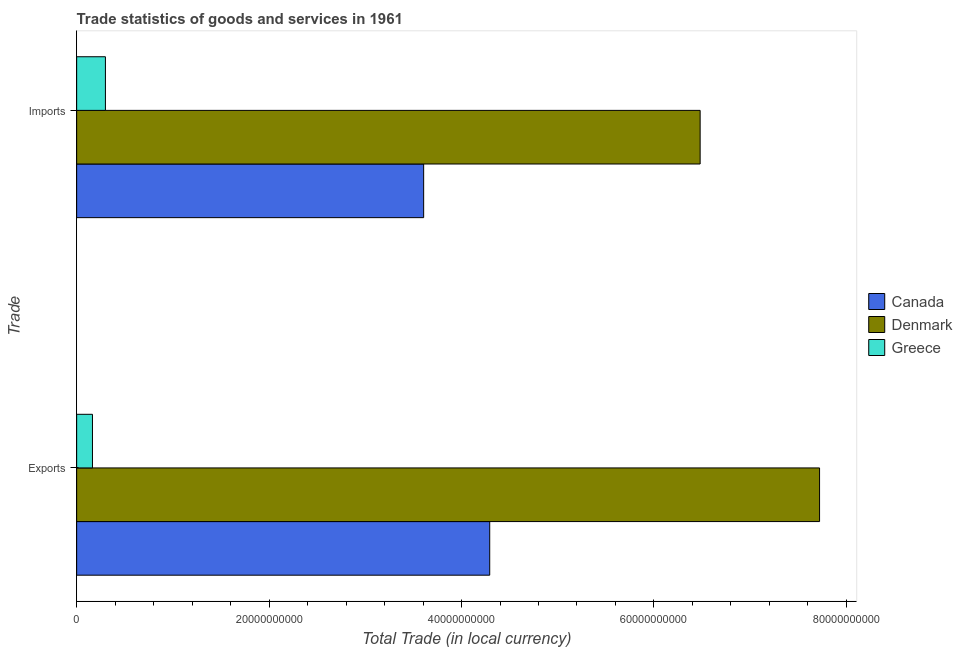How many different coloured bars are there?
Keep it short and to the point. 3. How many groups of bars are there?
Your response must be concise. 2. Are the number of bars per tick equal to the number of legend labels?
Make the answer very short. Yes. How many bars are there on the 2nd tick from the top?
Make the answer very short. 3. What is the label of the 1st group of bars from the top?
Your answer should be compact. Imports. What is the imports of goods and services in Greece?
Your answer should be very brief. 2.99e+09. Across all countries, what is the maximum imports of goods and services?
Offer a very short reply. 6.48e+1. Across all countries, what is the minimum export of goods and services?
Offer a very short reply. 1.64e+09. In which country was the export of goods and services maximum?
Offer a terse response. Denmark. What is the total imports of goods and services in the graph?
Provide a short and direct response. 1.04e+11. What is the difference between the imports of goods and services in Canada and that in Denmark?
Ensure brevity in your answer.  -2.87e+1. What is the difference between the imports of goods and services in Greece and the export of goods and services in Canada?
Provide a short and direct response. -3.99e+1. What is the average export of goods and services per country?
Your answer should be very brief. 4.06e+1. What is the difference between the imports of goods and services and export of goods and services in Denmark?
Offer a terse response. -1.24e+1. What is the ratio of the export of goods and services in Canada to that in Denmark?
Give a very brief answer. 0.56. In how many countries, is the export of goods and services greater than the average export of goods and services taken over all countries?
Your answer should be very brief. 2. What does the 1st bar from the top in Imports represents?
Offer a very short reply. Greece. What does the 1st bar from the bottom in Imports represents?
Offer a terse response. Canada. Are all the bars in the graph horizontal?
Make the answer very short. Yes. What is the difference between two consecutive major ticks on the X-axis?
Your answer should be very brief. 2.00e+1. Does the graph contain any zero values?
Keep it short and to the point. No. How are the legend labels stacked?
Offer a terse response. Vertical. What is the title of the graph?
Your answer should be very brief. Trade statistics of goods and services in 1961. Does "Somalia" appear as one of the legend labels in the graph?
Your response must be concise. No. What is the label or title of the X-axis?
Give a very brief answer. Total Trade (in local currency). What is the label or title of the Y-axis?
Offer a terse response. Trade. What is the Total Trade (in local currency) of Canada in Exports?
Your answer should be very brief. 4.29e+1. What is the Total Trade (in local currency) of Denmark in Exports?
Make the answer very short. 7.72e+1. What is the Total Trade (in local currency) in Greece in Exports?
Provide a short and direct response. 1.64e+09. What is the Total Trade (in local currency) in Canada in Imports?
Offer a very short reply. 3.61e+1. What is the Total Trade (in local currency) in Denmark in Imports?
Provide a short and direct response. 6.48e+1. What is the Total Trade (in local currency) of Greece in Imports?
Your response must be concise. 2.99e+09. Across all Trade, what is the maximum Total Trade (in local currency) in Canada?
Offer a terse response. 4.29e+1. Across all Trade, what is the maximum Total Trade (in local currency) of Denmark?
Provide a short and direct response. 7.72e+1. Across all Trade, what is the maximum Total Trade (in local currency) in Greece?
Keep it short and to the point. 2.99e+09. Across all Trade, what is the minimum Total Trade (in local currency) in Canada?
Keep it short and to the point. 3.61e+1. Across all Trade, what is the minimum Total Trade (in local currency) in Denmark?
Offer a terse response. 6.48e+1. Across all Trade, what is the minimum Total Trade (in local currency) of Greece?
Make the answer very short. 1.64e+09. What is the total Total Trade (in local currency) of Canada in the graph?
Provide a succinct answer. 7.90e+1. What is the total Total Trade (in local currency) in Denmark in the graph?
Your answer should be compact. 1.42e+11. What is the total Total Trade (in local currency) of Greece in the graph?
Offer a very short reply. 4.63e+09. What is the difference between the Total Trade (in local currency) of Canada in Exports and that in Imports?
Your answer should be very brief. 6.87e+09. What is the difference between the Total Trade (in local currency) of Denmark in Exports and that in Imports?
Offer a terse response. 1.24e+1. What is the difference between the Total Trade (in local currency) in Greece in Exports and that in Imports?
Offer a terse response. -1.35e+09. What is the difference between the Total Trade (in local currency) of Canada in Exports and the Total Trade (in local currency) of Denmark in Imports?
Offer a very short reply. -2.19e+1. What is the difference between the Total Trade (in local currency) in Canada in Exports and the Total Trade (in local currency) in Greece in Imports?
Provide a succinct answer. 3.99e+1. What is the difference between the Total Trade (in local currency) in Denmark in Exports and the Total Trade (in local currency) in Greece in Imports?
Your response must be concise. 7.42e+1. What is the average Total Trade (in local currency) in Canada per Trade?
Your answer should be very brief. 3.95e+1. What is the average Total Trade (in local currency) of Denmark per Trade?
Your answer should be very brief. 7.10e+1. What is the average Total Trade (in local currency) in Greece per Trade?
Your response must be concise. 2.32e+09. What is the difference between the Total Trade (in local currency) in Canada and Total Trade (in local currency) in Denmark in Exports?
Your answer should be compact. -3.43e+1. What is the difference between the Total Trade (in local currency) of Canada and Total Trade (in local currency) of Greece in Exports?
Your answer should be very brief. 4.13e+1. What is the difference between the Total Trade (in local currency) in Denmark and Total Trade (in local currency) in Greece in Exports?
Provide a short and direct response. 7.56e+1. What is the difference between the Total Trade (in local currency) of Canada and Total Trade (in local currency) of Denmark in Imports?
Your answer should be compact. -2.87e+1. What is the difference between the Total Trade (in local currency) of Canada and Total Trade (in local currency) of Greece in Imports?
Your response must be concise. 3.31e+1. What is the difference between the Total Trade (in local currency) in Denmark and Total Trade (in local currency) in Greece in Imports?
Provide a succinct answer. 6.18e+1. What is the ratio of the Total Trade (in local currency) of Canada in Exports to that in Imports?
Ensure brevity in your answer.  1.19. What is the ratio of the Total Trade (in local currency) of Denmark in Exports to that in Imports?
Keep it short and to the point. 1.19. What is the ratio of the Total Trade (in local currency) of Greece in Exports to that in Imports?
Keep it short and to the point. 0.55. What is the difference between the highest and the second highest Total Trade (in local currency) in Canada?
Ensure brevity in your answer.  6.87e+09. What is the difference between the highest and the second highest Total Trade (in local currency) of Denmark?
Offer a terse response. 1.24e+1. What is the difference between the highest and the second highest Total Trade (in local currency) in Greece?
Make the answer very short. 1.35e+09. What is the difference between the highest and the lowest Total Trade (in local currency) in Canada?
Ensure brevity in your answer.  6.87e+09. What is the difference between the highest and the lowest Total Trade (in local currency) in Denmark?
Provide a succinct answer. 1.24e+1. What is the difference between the highest and the lowest Total Trade (in local currency) of Greece?
Offer a very short reply. 1.35e+09. 